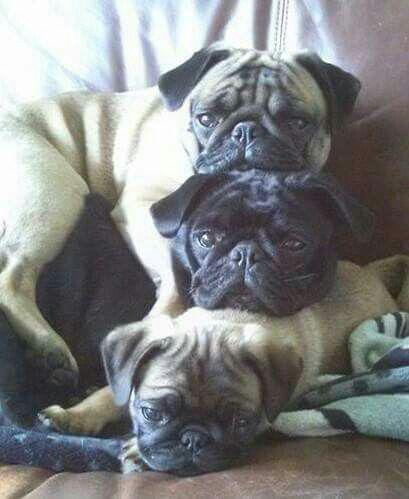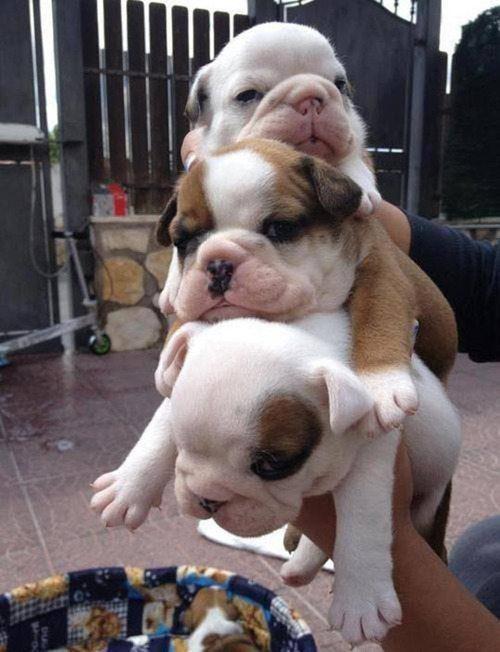The first image is the image on the left, the second image is the image on the right. For the images shown, is this caption "There are more dogs in the image on the right." true? Answer yes or no. No. The first image is the image on the left, the second image is the image on the right. Considering the images on both sides, is "Each image includes buff-beige pugs with dark muzzles, and no image contains fewer than three pugs." valid? Answer yes or no. No. 